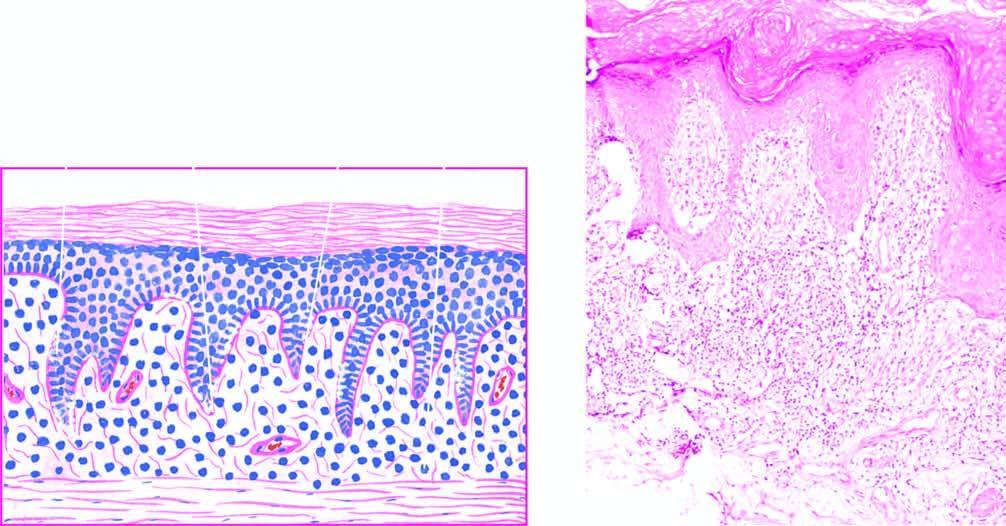what shows liquefactive degeneration?
Answer the question using a single word or phrase. Basal layer 